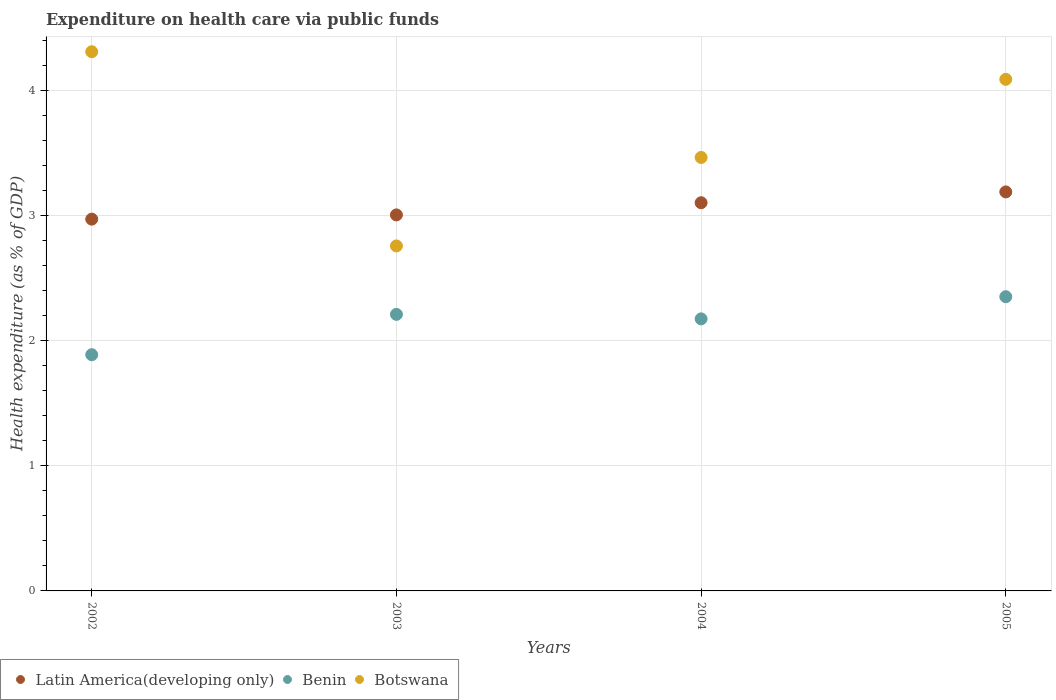How many different coloured dotlines are there?
Offer a very short reply. 3. What is the expenditure made on health care in Latin America(developing only) in 2004?
Offer a very short reply. 3.1. Across all years, what is the maximum expenditure made on health care in Botswana?
Provide a short and direct response. 4.31. Across all years, what is the minimum expenditure made on health care in Latin America(developing only)?
Make the answer very short. 2.97. What is the total expenditure made on health care in Benin in the graph?
Your response must be concise. 8.63. What is the difference between the expenditure made on health care in Benin in 2002 and that in 2004?
Keep it short and to the point. -0.29. What is the difference between the expenditure made on health care in Latin America(developing only) in 2002 and the expenditure made on health care in Benin in 2005?
Make the answer very short. 0.62. What is the average expenditure made on health care in Botswana per year?
Give a very brief answer. 3.66. In the year 2004, what is the difference between the expenditure made on health care in Benin and expenditure made on health care in Botswana?
Your answer should be very brief. -1.29. What is the ratio of the expenditure made on health care in Latin America(developing only) in 2002 to that in 2003?
Your answer should be compact. 0.99. Is the expenditure made on health care in Botswana in 2002 less than that in 2005?
Keep it short and to the point. No. Is the difference between the expenditure made on health care in Benin in 2003 and 2005 greater than the difference between the expenditure made on health care in Botswana in 2003 and 2005?
Ensure brevity in your answer.  Yes. What is the difference between the highest and the second highest expenditure made on health care in Latin America(developing only)?
Your answer should be very brief. 0.09. What is the difference between the highest and the lowest expenditure made on health care in Latin America(developing only)?
Provide a succinct answer. 0.22. Is the sum of the expenditure made on health care in Botswana in 2002 and 2005 greater than the maximum expenditure made on health care in Latin America(developing only) across all years?
Your answer should be compact. Yes. Is it the case that in every year, the sum of the expenditure made on health care in Botswana and expenditure made on health care in Benin  is greater than the expenditure made on health care in Latin America(developing only)?
Give a very brief answer. Yes. Does the expenditure made on health care in Botswana monotonically increase over the years?
Offer a very short reply. No. Is the expenditure made on health care in Benin strictly less than the expenditure made on health care in Latin America(developing only) over the years?
Offer a very short reply. Yes. How many years are there in the graph?
Your answer should be compact. 4. What is the difference between two consecutive major ticks on the Y-axis?
Keep it short and to the point. 1. Does the graph contain grids?
Give a very brief answer. Yes. How many legend labels are there?
Give a very brief answer. 3. What is the title of the graph?
Provide a short and direct response. Expenditure on health care via public funds. Does "North America" appear as one of the legend labels in the graph?
Provide a succinct answer. No. What is the label or title of the Y-axis?
Provide a succinct answer. Health expenditure (as % of GDP). What is the Health expenditure (as % of GDP) in Latin America(developing only) in 2002?
Make the answer very short. 2.97. What is the Health expenditure (as % of GDP) of Benin in 2002?
Provide a succinct answer. 1.89. What is the Health expenditure (as % of GDP) of Botswana in 2002?
Provide a short and direct response. 4.31. What is the Health expenditure (as % of GDP) of Latin America(developing only) in 2003?
Your answer should be compact. 3.01. What is the Health expenditure (as % of GDP) in Benin in 2003?
Ensure brevity in your answer.  2.21. What is the Health expenditure (as % of GDP) of Botswana in 2003?
Provide a succinct answer. 2.76. What is the Health expenditure (as % of GDP) of Latin America(developing only) in 2004?
Offer a very short reply. 3.1. What is the Health expenditure (as % of GDP) in Benin in 2004?
Make the answer very short. 2.18. What is the Health expenditure (as % of GDP) of Botswana in 2004?
Your answer should be compact. 3.47. What is the Health expenditure (as % of GDP) of Latin America(developing only) in 2005?
Your response must be concise. 3.19. What is the Health expenditure (as % of GDP) of Benin in 2005?
Your answer should be compact. 2.35. What is the Health expenditure (as % of GDP) in Botswana in 2005?
Offer a terse response. 4.09. Across all years, what is the maximum Health expenditure (as % of GDP) of Latin America(developing only)?
Offer a terse response. 3.19. Across all years, what is the maximum Health expenditure (as % of GDP) of Benin?
Your answer should be compact. 2.35. Across all years, what is the maximum Health expenditure (as % of GDP) in Botswana?
Offer a very short reply. 4.31. Across all years, what is the minimum Health expenditure (as % of GDP) of Latin America(developing only)?
Make the answer very short. 2.97. Across all years, what is the minimum Health expenditure (as % of GDP) of Benin?
Offer a very short reply. 1.89. Across all years, what is the minimum Health expenditure (as % of GDP) of Botswana?
Keep it short and to the point. 2.76. What is the total Health expenditure (as % of GDP) in Latin America(developing only) in the graph?
Your answer should be compact. 12.27. What is the total Health expenditure (as % of GDP) in Benin in the graph?
Your answer should be compact. 8.63. What is the total Health expenditure (as % of GDP) in Botswana in the graph?
Give a very brief answer. 14.63. What is the difference between the Health expenditure (as % of GDP) in Latin America(developing only) in 2002 and that in 2003?
Your answer should be very brief. -0.03. What is the difference between the Health expenditure (as % of GDP) of Benin in 2002 and that in 2003?
Ensure brevity in your answer.  -0.32. What is the difference between the Health expenditure (as % of GDP) of Botswana in 2002 and that in 2003?
Your response must be concise. 1.55. What is the difference between the Health expenditure (as % of GDP) of Latin America(developing only) in 2002 and that in 2004?
Your response must be concise. -0.13. What is the difference between the Health expenditure (as % of GDP) in Benin in 2002 and that in 2004?
Keep it short and to the point. -0.29. What is the difference between the Health expenditure (as % of GDP) of Botswana in 2002 and that in 2004?
Offer a terse response. 0.85. What is the difference between the Health expenditure (as % of GDP) in Latin America(developing only) in 2002 and that in 2005?
Ensure brevity in your answer.  -0.22. What is the difference between the Health expenditure (as % of GDP) of Benin in 2002 and that in 2005?
Make the answer very short. -0.46. What is the difference between the Health expenditure (as % of GDP) in Botswana in 2002 and that in 2005?
Keep it short and to the point. 0.22. What is the difference between the Health expenditure (as % of GDP) in Latin America(developing only) in 2003 and that in 2004?
Provide a short and direct response. -0.1. What is the difference between the Health expenditure (as % of GDP) of Benin in 2003 and that in 2004?
Your response must be concise. 0.04. What is the difference between the Health expenditure (as % of GDP) in Botswana in 2003 and that in 2004?
Provide a succinct answer. -0.71. What is the difference between the Health expenditure (as % of GDP) of Latin America(developing only) in 2003 and that in 2005?
Make the answer very short. -0.18. What is the difference between the Health expenditure (as % of GDP) in Benin in 2003 and that in 2005?
Provide a short and direct response. -0.14. What is the difference between the Health expenditure (as % of GDP) of Botswana in 2003 and that in 2005?
Offer a very short reply. -1.33. What is the difference between the Health expenditure (as % of GDP) of Latin America(developing only) in 2004 and that in 2005?
Make the answer very short. -0.09. What is the difference between the Health expenditure (as % of GDP) of Benin in 2004 and that in 2005?
Offer a very short reply. -0.18. What is the difference between the Health expenditure (as % of GDP) of Botswana in 2004 and that in 2005?
Give a very brief answer. -0.62. What is the difference between the Health expenditure (as % of GDP) in Latin America(developing only) in 2002 and the Health expenditure (as % of GDP) in Benin in 2003?
Keep it short and to the point. 0.76. What is the difference between the Health expenditure (as % of GDP) of Latin America(developing only) in 2002 and the Health expenditure (as % of GDP) of Botswana in 2003?
Keep it short and to the point. 0.21. What is the difference between the Health expenditure (as % of GDP) in Benin in 2002 and the Health expenditure (as % of GDP) in Botswana in 2003?
Provide a succinct answer. -0.87. What is the difference between the Health expenditure (as % of GDP) in Latin America(developing only) in 2002 and the Health expenditure (as % of GDP) in Benin in 2004?
Your answer should be very brief. 0.8. What is the difference between the Health expenditure (as % of GDP) in Latin America(developing only) in 2002 and the Health expenditure (as % of GDP) in Botswana in 2004?
Your answer should be very brief. -0.49. What is the difference between the Health expenditure (as % of GDP) in Benin in 2002 and the Health expenditure (as % of GDP) in Botswana in 2004?
Provide a succinct answer. -1.58. What is the difference between the Health expenditure (as % of GDP) of Latin America(developing only) in 2002 and the Health expenditure (as % of GDP) of Benin in 2005?
Keep it short and to the point. 0.62. What is the difference between the Health expenditure (as % of GDP) of Latin America(developing only) in 2002 and the Health expenditure (as % of GDP) of Botswana in 2005?
Your response must be concise. -1.12. What is the difference between the Health expenditure (as % of GDP) in Benin in 2002 and the Health expenditure (as % of GDP) in Botswana in 2005?
Ensure brevity in your answer.  -2.2. What is the difference between the Health expenditure (as % of GDP) of Latin America(developing only) in 2003 and the Health expenditure (as % of GDP) of Benin in 2004?
Your response must be concise. 0.83. What is the difference between the Health expenditure (as % of GDP) of Latin America(developing only) in 2003 and the Health expenditure (as % of GDP) of Botswana in 2004?
Make the answer very short. -0.46. What is the difference between the Health expenditure (as % of GDP) of Benin in 2003 and the Health expenditure (as % of GDP) of Botswana in 2004?
Provide a succinct answer. -1.25. What is the difference between the Health expenditure (as % of GDP) in Latin America(developing only) in 2003 and the Health expenditure (as % of GDP) in Benin in 2005?
Your response must be concise. 0.65. What is the difference between the Health expenditure (as % of GDP) in Latin America(developing only) in 2003 and the Health expenditure (as % of GDP) in Botswana in 2005?
Provide a succinct answer. -1.08. What is the difference between the Health expenditure (as % of GDP) in Benin in 2003 and the Health expenditure (as % of GDP) in Botswana in 2005?
Your answer should be very brief. -1.88. What is the difference between the Health expenditure (as % of GDP) in Latin America(developing only) in 2004 and the Health expenditure (as % of GDP) in Benin in 2005?
Keep it short and to the point. 0.75. What is the difference between the Health expenditure (as % of GDP) of Latin America(developing only) in 2004 and the Health expenditure (as % of GDP) of Botswana in 2005?
Your answer should be very brief. -0.99. What is the difference between the Health expenditure (as % of GDP) of Benin in 2004 and the Health expenditure (as % of GDP) of Botswana in 2005?
Your answer should be compact. -1.92. What is the average Health expenditure (as % of GDP) in Latin America(developing only) per year?
Provide a succinct answer. 3.07. What is the average Health expenditure (as % of GDP) in Benin per year?
Provide a succinct answer. 2.16. What is the average Health expenditure (as % of GDP) in Botswana per year?
Keep it short and to the point. 3.66. In the year 2002, what is the difference between the Health expenditure (as % of GDP) in Latin America(developing only) and Health expenditure (as % of GDP) in Benin?
Keep it short and to the point. 1.08. In the year 2002, what is the difference between the Health expenditure (as % of GDP) in Latin America(developing only) and Health expenditure (as % of GDP) in Botswana?
Provide a short and direct response. -1.34. In the year 2002, what is the difference between the Health expenditure (as % of GDP) of Benin and Health expenditure (as % of GDP) of Botswana?
Your answer should be very brief. -2.42. In the year 2003, what is the difference between the Health expenditure (as % of GDP) in Latin America(developing only) and Health expenditure (as % of GDP) in Benin?
Your answer should be very brief. 0.8. In the year 2003, what is the difference between the Health expenditure (as % of GDP) of Latin America(developing only) and Health expenditure (as % of GDP) of Botswana?
Offer a very short reply. 0.25. In the year 2003, what is the difference between the Health expenditure (as % of GDP) of Benin and Health expenditure (as % of GDP) of Botswana?
Make the answer very short. -0.55. In the year 2004, what is the difference between the Health expenditure (as % of GDP) in Latin America(developing only) and Health expenditure (as % of GDP) in Benin?
Offer a terse response. 0.93. In the year 2004, what is the difference between the Health expenditure (as % of GDP) of Latin America(developing only) and Health expenditure (as % of GDP) of Botswana?
Your answer should be very brief. -0.36. In the year 2004, what is the difference between the Health expenditure (as % of GDP) of Benin and Health expenditure (as % of GDP) of Botswana?
Provide a short and direct response. -1.29. In the year 2005, what is the difference between the Health expenditure (as % of GDP) in Latin America(developing only) and Health expenditure (as % of GDP) in Benin?
Make the answer very short. 0.84. In the year 2005, what is the difference between the Health expenditure (as % of GDP) in Latin America(developing only) and Health expenditure (as % of GDP) in Botswana?
Your response must be concise. -0.9. In the year 2005, what is the difference between the Health expenditure (as % of GDP) of Benin and Health expenditure (as % of GDP) of Botswana?
Your response must be concise. -1.74. What is the ratio of the Health expenditure (as % of GDP) in Latin America(developing only) in 2002 to that in 2003?
Provide a short and direct response. 0.99. What is the ratio of the Health expenditure (as % of GDP) of Benin in 2002 to that in 2003?
Offer a terse response. 0.85. What is the ratio of the Health expenditure (as % of GDP) of Botswana in 2002 to that in 2003?
Give a very brief answer. 1.56. What is the ratio of the Health expenditure (as % of GDP) in Latin America(developing only) in 2002 to that in 2004?
Provide a succinct answer. 0.96. What is the ratio of the Health expenditure (as % of GDP) of Benin in 2002 to that in 2004?
Offer a terse response. 0.87. What is the ratio of the Health expenditure (as % of GDP) of Botswana in 2002 to that in 2004?
Ensure brevity in your answer.  1.24. What is the ratio of the Health expenditure (as % of GDP) of Latin America(developing only) in 2002 to that in 2005?
Keep it short and to the point. 0.93. What is the ratio of the Health expenditure (as % of GDP) of Benin in 2002 to that in 2005?
Ensure brevity in your answer.  0.8. What is the ratio of the Health expenditure (as % of GDP) of Botswana in 2002 to that in 2005?
Offer a terse response. 1.05. What is the ratio of the Health expenditure (as % of GDP) in Latin America(developing only) in 2003 to that in 2004?
Provide a short and direct response. 0.97. What is the ratio of the Health expenditure (as % of GDP) in Benin in 2003 to that in 2004?
Your response must be concise. 1.02. What is the ratio of the Health expenditure (as % of GDP) in Botswana in 2003 to that in 2004?
Make the answer very short. 0.8. What is the ratio of the Health expenditure (as % of GDP) of Latin America(developing only) in 2003 to that in 2005?
Provide a succinct answer. 0.94. What is the ratio of the Health expenditure (as % of GDP) in Botswana in 2003 to that in 2005?
Offer a terse response. 0.67. What is the ratio of the Health expenditure (as % of GDP) of Latin America(developing only) in 2004 to that in 2005?
Your response must be concise. 0.97. What is the ratio of the Health expenditure (as % of GDP) of Benin in 2004 to that in 2005?
Give a very brief answer. 0.92. What is the ratio of the Health expenditure (as % of GDP) of Botswana in 2004 to that in 2005?
Keep it short and to the point. 0.85. What is the difference between the highest and the second highest Health expenditure (as % of GDP) in Latin America(developing only)?
Offer a terse response. 0.09. What is the difference between the highest and the second highest Health expenditure (as % of GDP) of Benin?
Offer a very short reply. 0.14. What is the difference between the highest and the second highest Health expenditure (as % of GDP) of Botswana?
Your answer should be very brief. 0.22. What is the difference between the highest and the lowest Health expenditure (as % of GDP) of Latin America(developing only)?
Offer a terse response. 0.22. What is the difference between the highest and the lowest Health expenditure (as % of GDP) of Benin?
Offer a terse response. 0.46. What is the difference between the highest and the lowest Health expenditure (as % of GDP) in Botswana?
Make the answer very short. 1.55. 